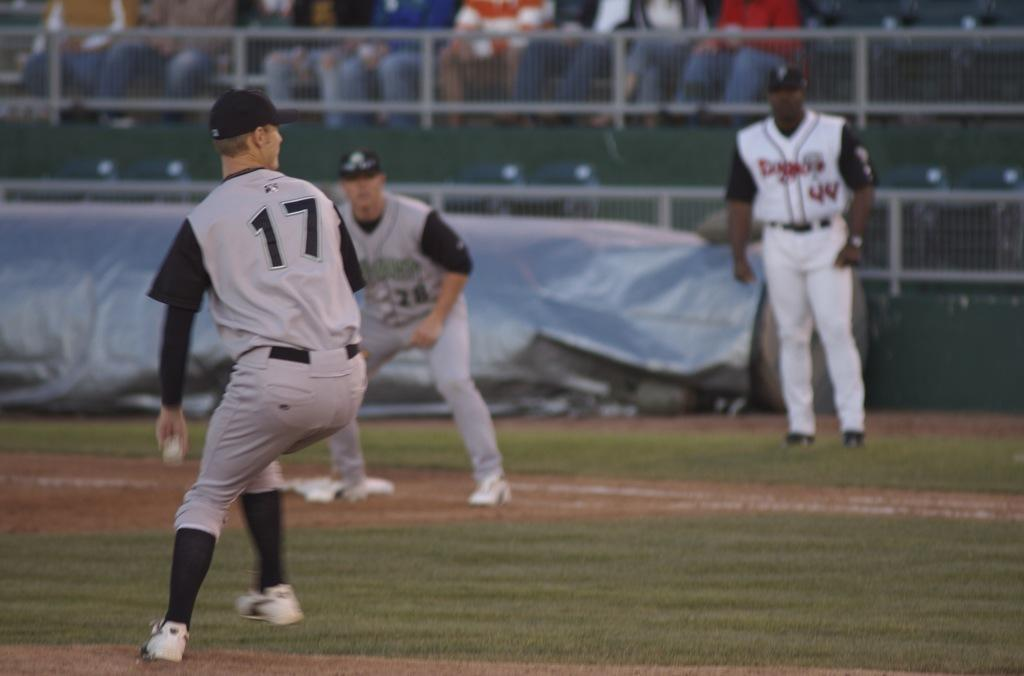<image>
Write a terse but informative summary of the picture. Number 17 gets ready to throw the ball while 2 other players look on. 